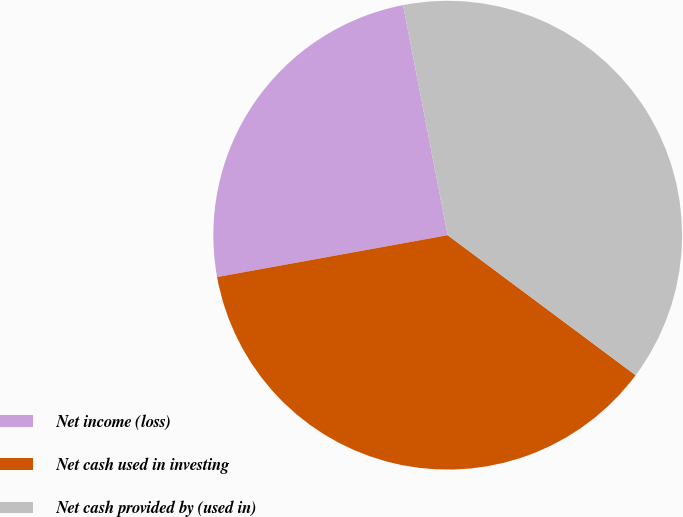Convert chart. <chart><loc_0><loc_0><loc_500><loc_500><pie_chart><fcel>Net income (loss)<fcel>Net cash used in investing<fcel>Net cash provided by (used in)<nl><fcel>24.81%<fcel>36.95%<fcel>38.24%<nl></chart> 